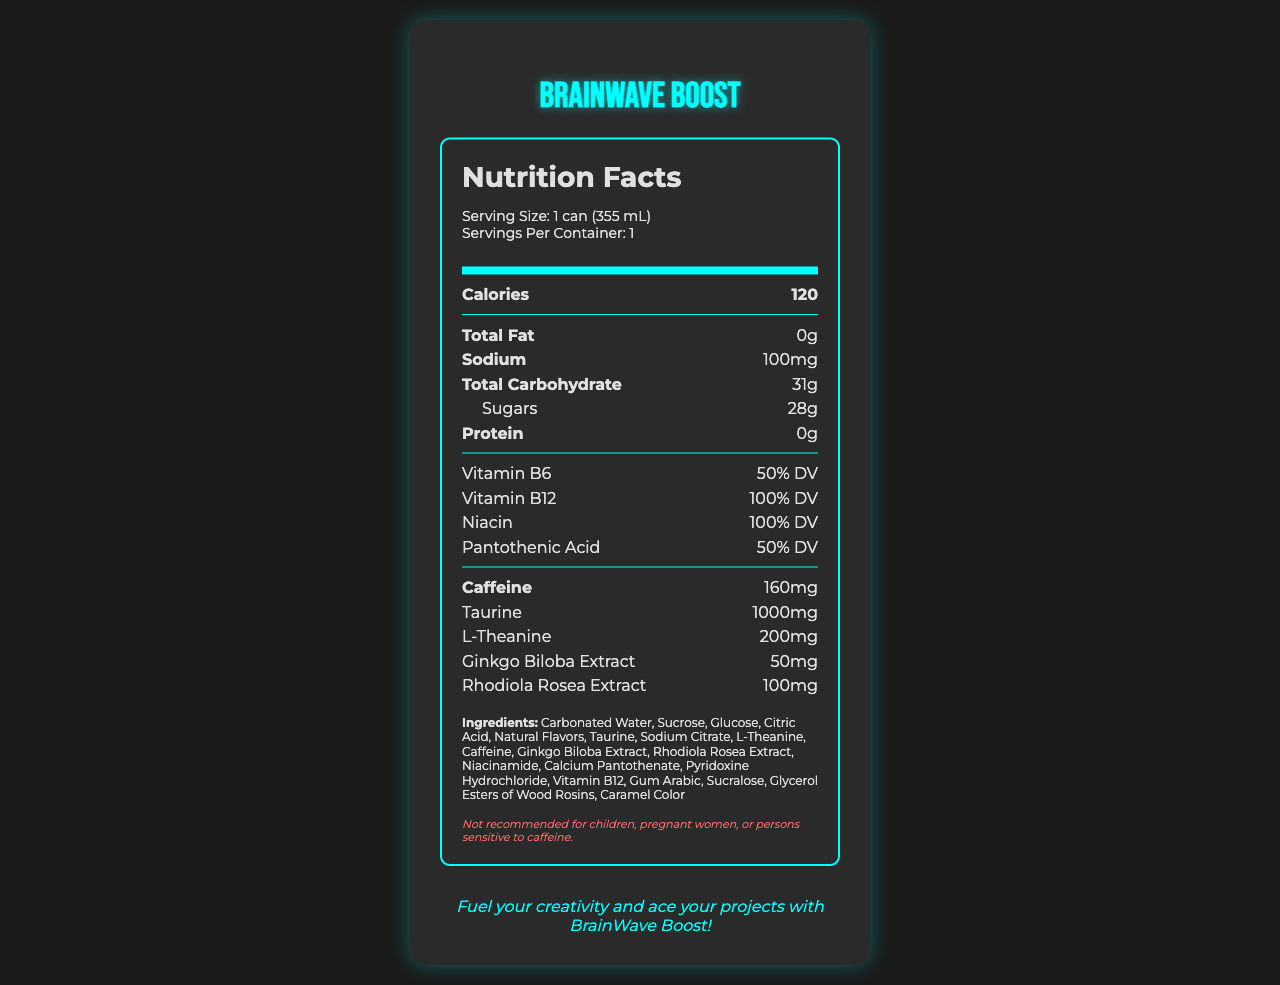what is the serving size of BrainWave Boost? The document lists the serving size as "1 can (355 mL)" in the nutrition label section.
Answer: 1 can (355 mL) how many calories are in one serving of BrainWave Boost? The document specifies that one serving contains 120 calories.
Answer: 120 name two benefits mentioned in the document that BrainWave Boost offers. The document states that BrainWave Boost offers "Enhanced mental focus" and "Improved cognitive performance" among its key benefits.
Answer: Enhanced mental focus, Improved cognitive performance how much caffeine does one can of BrainWave Boost contain? The nutrition label indicates that each serving, which is one can, contains 160 mg of caffeine.
Answer: 160 mg are there any allergens that consumers should be aware of according to the document? The allergen information section states that the product is "Produced in a facility that also processes soy and milk products."
Answer: Yes which ingredient is listed first in the ingredients section? The ingredient list begins with "Carbonated Water".
Answer: Carbonated Water what percentage of the daily value of Vitamin B12 does BrainWave Boost provide per serving? The nutrition label indicates that the product provides 100% DV of Vitamin B12 per serving.
Answer: 100% DV how many grams of sugars are in one can of BrainWave Boost? The nutrition label states that one can contains 28 grams of sugars.
Answer: 28 grams which of the following ingredients is NOT listed in BrainWave Boost's ingredients? A. Sucralose B. Aspartame C. Sucrose D. Glucose Aspartame is not listed among the ingredients.
Answer: B based on the document, which target audience is BrainWave Boost marketed towards? A. Athletes B. Children C. Creative professionals and university students D. Senior citizens The document states the target audience as "Creative professionals and university students".
Answer: C is it recommended for children to consume BrainWave Boost? The disclaimer section states that it is "Not recommended for children, pregnant women, or persons sensitive to caffeine."
Answer: No summarize the main idea of the BrainWave Boost document. The summary covers the key elements, including the drink's purpose, nutritional details, target audience, allergen info, and marketing.
Answer: BrainWave Boost is an energy drink designed for creative professionals and university students, providing enhanced mental focus and cognitive performance. The label offers detailed nutritional information, ingredients, allergen warnings, and a disclaimer about its suitability for specific groups. The drink comes in a sleek package and is available in select locations. how much taurine is included in one can of BrainWave Boost? The nutrition label indicates that each can contains 1,000 mg of taurine.
Answer: 1,000 mg does BrainWave Boost contain any fat? The nutrition label shows that the total fat content is 0 grams.
Answer: No what is the marketing tagline of BrainWave Boost? The tagline is displayed prominently in the marketing section of the document.
Answer: Fuel your creativity and ace your projects with BrainWave Boost! where can consumers purchase BrainWave Boost according to the document? A. Only online B. University cafeterias, art supply stores, and select coffee shops C. Supermarkets and grocery stores D. Fitness centers The distribution section states that BrainWave Boost is available at university cafeterias, art supply stores, and select coffee shops.
Answer: B what is the packaging design of BrainWave Boost? The packaging section describes it as a "Sleek, matte black can with neon blue accents."
Answer: Sleek, matte black can with neon blue accents how much sodium does one serving of BrainWave Boost contain? The nutritional information lists sodium content as 100 mg per serving.
Answer: 100 mg does the document mention the price of BrainWave Boost? The document does not provide any pricing information.
Answer: Cannot be determined is there information about how BrainWave Boost impacts physical performance? The document primarily focuses on cognitive performance and does not mention physical performance impacts.
Answer: No 